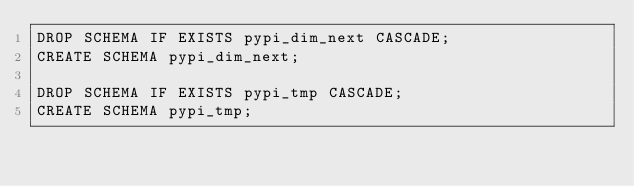<code> <loc_0><loc_0><loc_500><loc_500><_SQL_>DROP SCHEMA IF EXISTS pypi_dim_next CASCADE;
CREATE SCHEMA pypi_dim_next;

DROP SCHEMA IF EXISTS pypi_tmp CASCADE;
CREATE SCHEMA pypi_tmp;

</code> 